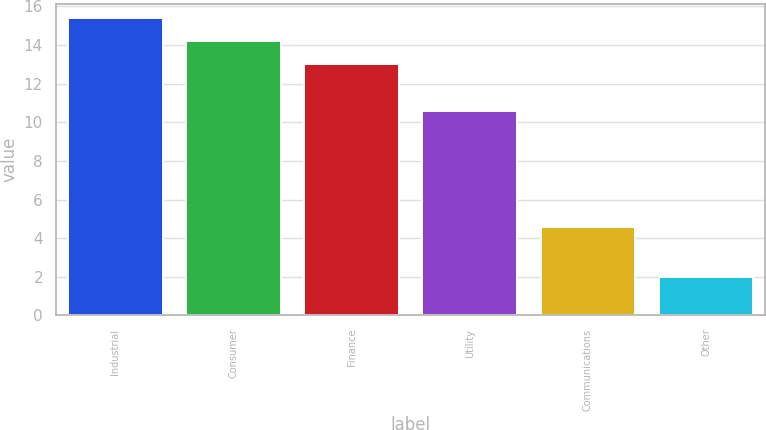Convert chart to OTSL. <chart><loc_0><loc_0><loc_500><loc_500><bar_chart><fcel>Industrial<fcel>Consumer<fcel>Finance<fcel>Utility<fcel>Communications<fcel>Other<nl><fcel>15.38<fcel>14.19<fcel>13<fcel>10.6<fcel>4.6<fcel>2<nl></chart> 